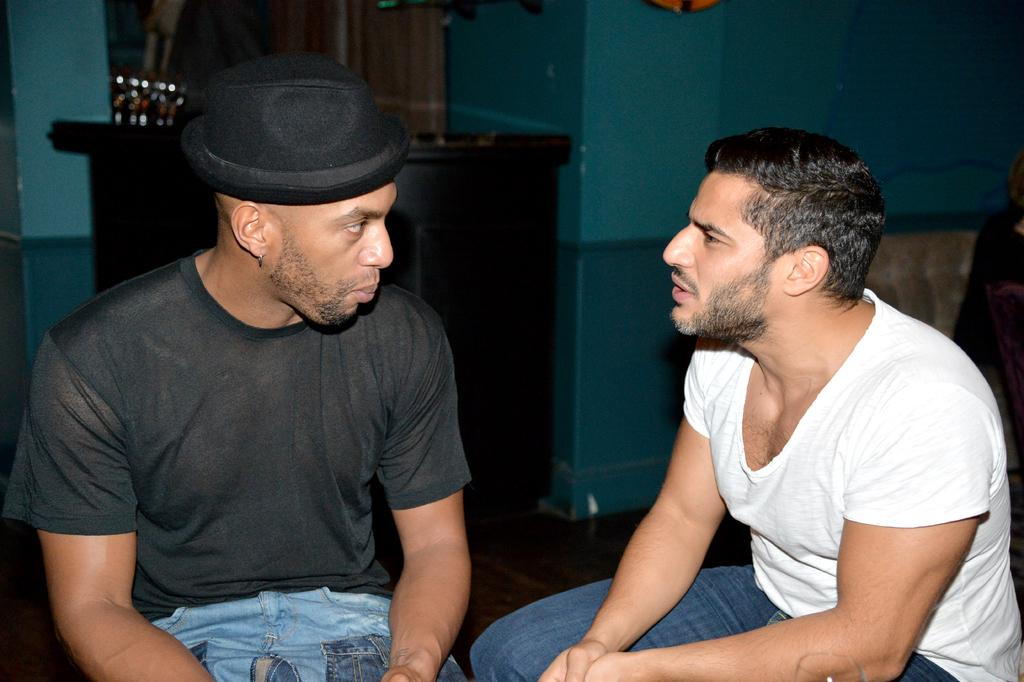How many people are in the image? There are two people in the image. What colors are the dresses worn by the people in the image? One person is wearing a white dress, one person is wearing a black dress, and one person is wearing a blue dress. What is visible in the background of the image? There is a table and a blue color wall in the background of the image. What type of sign can be seen hanging from the bat in the image? There is no bat or sign present in the image. What hobbies do the people in the image enjoy? The provided facts do not give any information about the hobbies of the people in the image. 